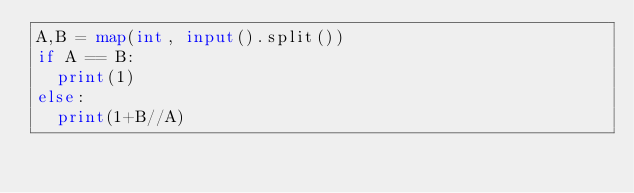<code> <loc_0><loc_0><loc_500><loc_500><_Python_>A,B = map(int, input().split())
if A == B:
  print(1)
else:
  print(1+B//A)</code> 